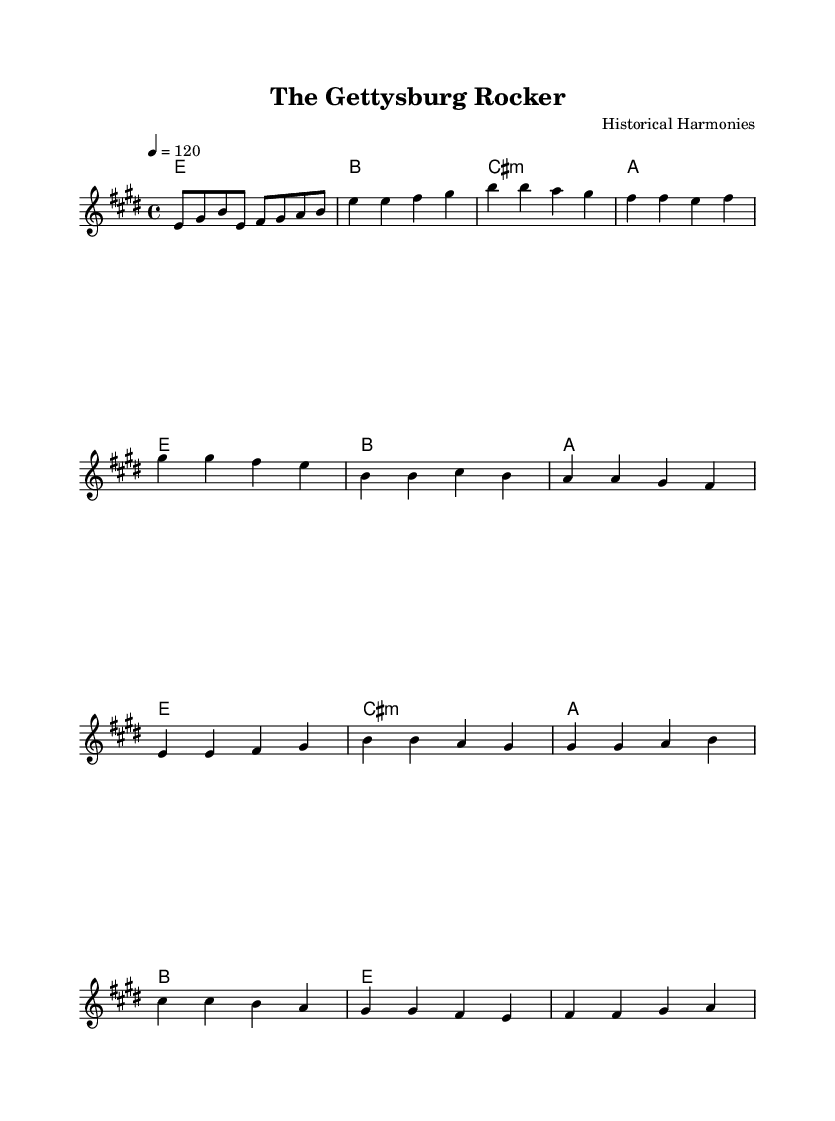What is the key signature of this music? The key signature is E major, which has four sharps: F#, C#, G#, and D#.
Answer: E major What is the time signature of this music? The time signature is 4/4, indicating there are four beats per measure.
Answer: 4/4 What is the tempo marking for this piece? The tempo marking indicates a speed of 120 beats per minute, which is specified as "4 = 120."
Answer: 120 How many measures are in the verse? Counting the distinct measures in the verse section, there are four measured bars.
Answer: 4 What is the primary theme addressed in the lyrics? The lyrics reference the historical event of the Battle of Gettysburg.
Answer: Gettysburg Which chord follows the bridge in the structure? After the bridge, the music returns to the verse chords, starting with E major.
Answer: E What makes this piece a classic rock anthem? It combines historical themes with a strong rhythm and melodic structure typical of classic rock anthems, emphasizing both narrative and musical energy.
Answer: Historical themes 